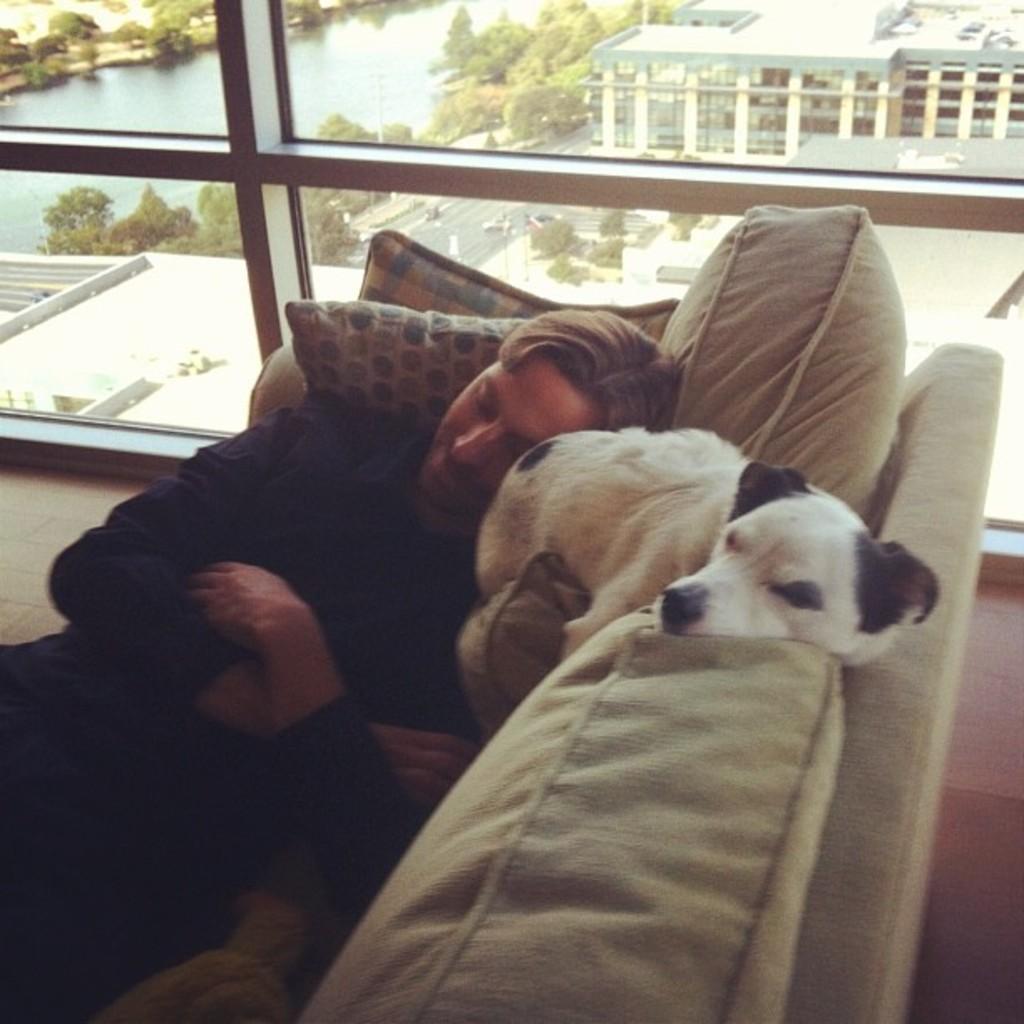Could you give a brief overview of what you see in this image? In this image we can see a man and a dog are sleeping on a sofa. This is a glass window. 